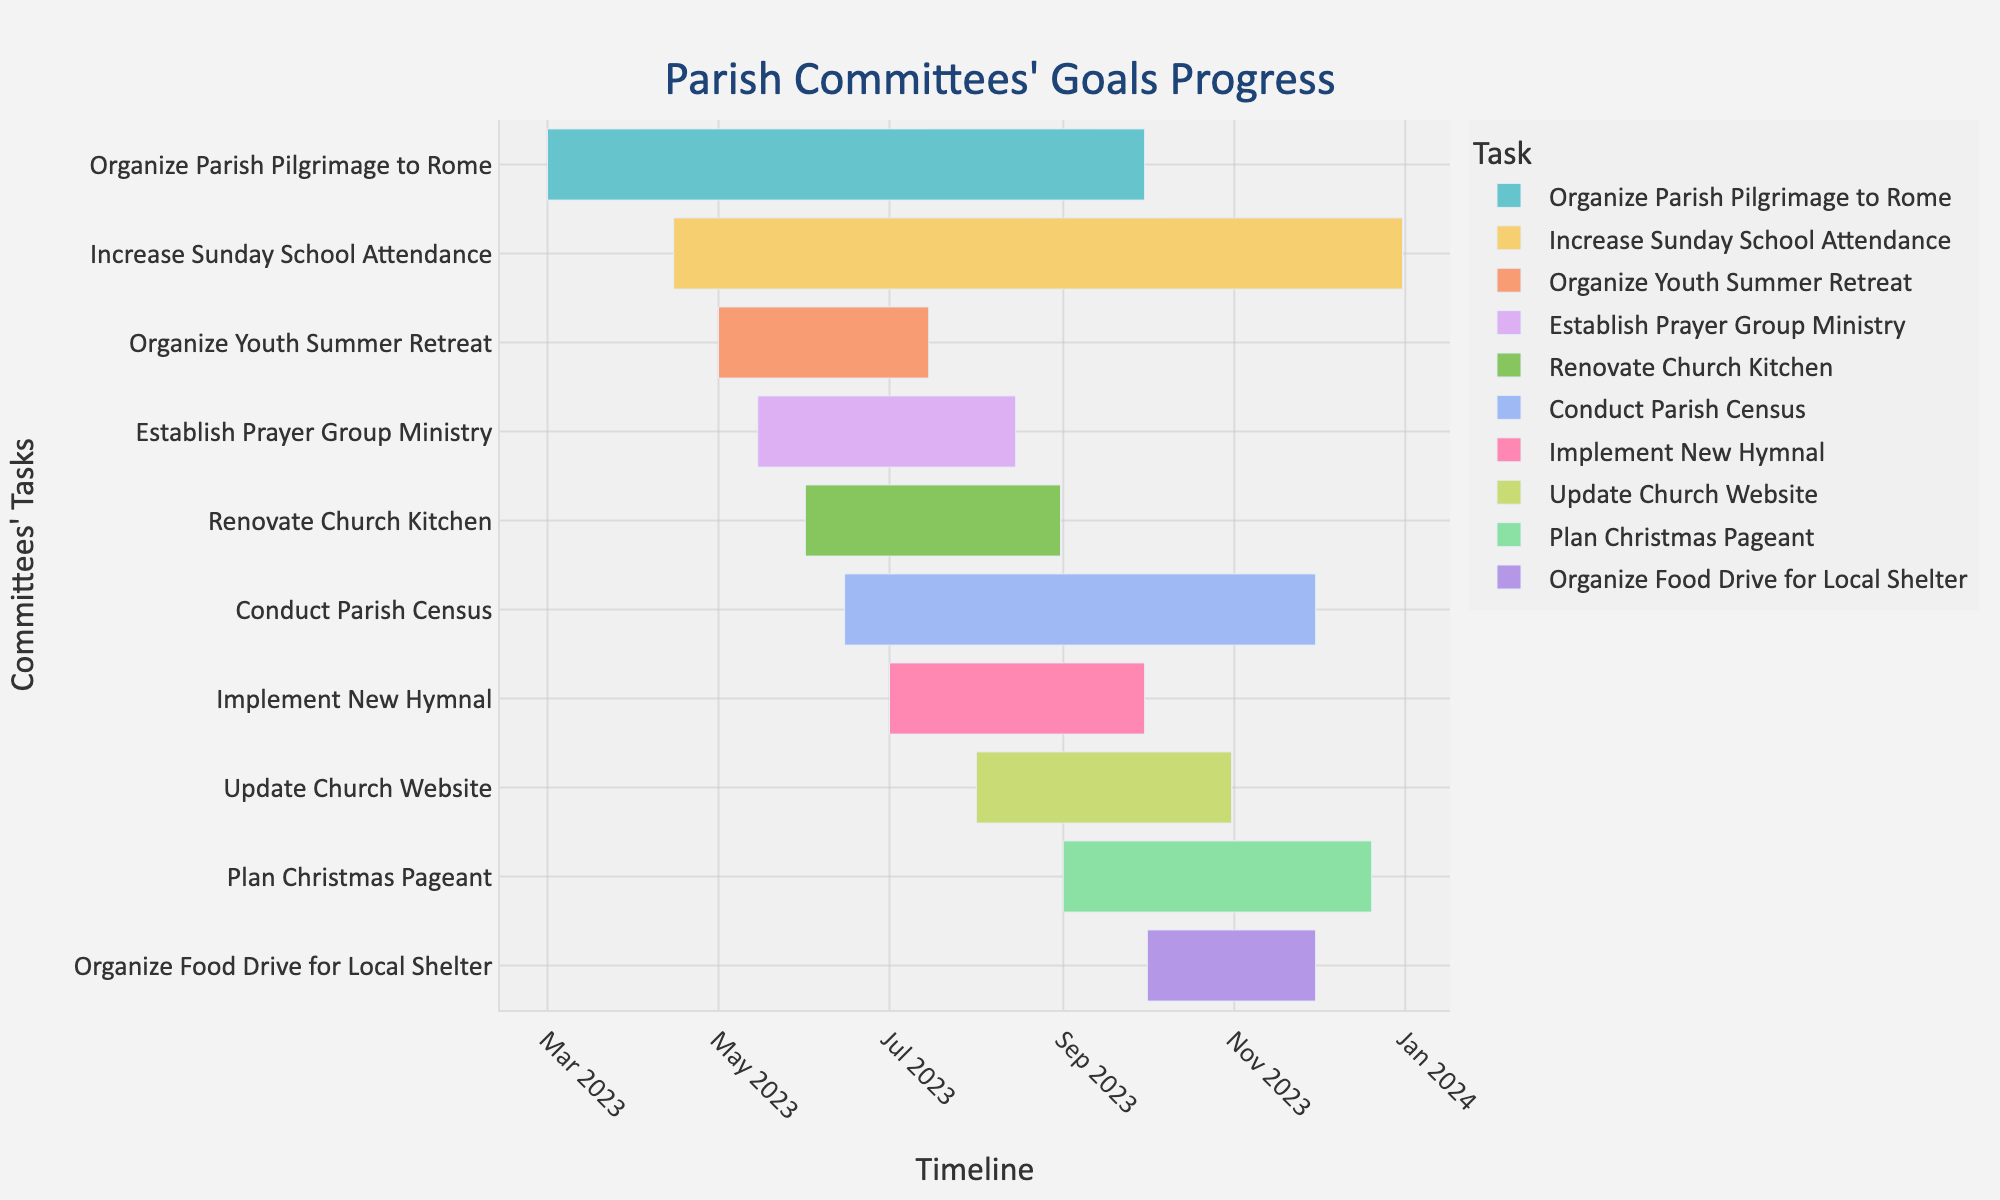How many tasks are represented on the Gantt chart? Count the number of distinct tasks listed on the y-axis.
Answer: 10 What is the title of the Gantt chart? Look at the top of the figure to read the title.
Answer: "Parish Committees' Goals Progress" Which task starts first on the timeline? Check the task with the earliest start date on the x-axis.
Answer: Organize Parish Pilgrimage to Rome Which task ends last on the timeline? Check the task with the latest end date on the x-axis.
Answer: Increase Sunday School Attendance Are there any tasks that have overlapping time periods? Look at the x-axis to see if the timelines of any tasks overlap.
Answer: Yes, many tasks overlap, such as Renovate Church Kitchen and Conduct Parish Census What is the duration of the task "Organize Youth Summer Retreat"? Subtract the start date from the end date for this task. May 1, 2023 to July 15, 2023 is 75 days.
Answer: 75 days Which task takes the longest to complete? Compare the durations of all tasks by checking the lengths of their bars on the chart.
Answer: Increase Sunday School Attendance Between which two tasks does the "Establish Prayer Group Ministry" task fall in terms of start date? Examine the start dates to determine which tasks start immediately before and after "Establish Prayer Group Ministry."
Answer: Organize Youth Summer Retreat and Renovate Church Kitchen Which tasks are ongoing concurrently between July and August? Identify tasks with timelines that include any part of July and August.
Answer: Organize Youth Summer Retreat, Renovate Church Kitchen, Implement New Hymnal, Establish Prayer Group Ministry, Organize Parish Pilgrimage to Rome What is the duration difference between "Update Church Website" and "Conduct Parish Census"? Calculate the duration of both tasks and find the difference. "Update Church Website" (August 1 to October 31) is 92 days and "Conduct Parish Census" (June 15 to November 30) is 169 days, so the difference is 77 days.
Answer: 77 days 